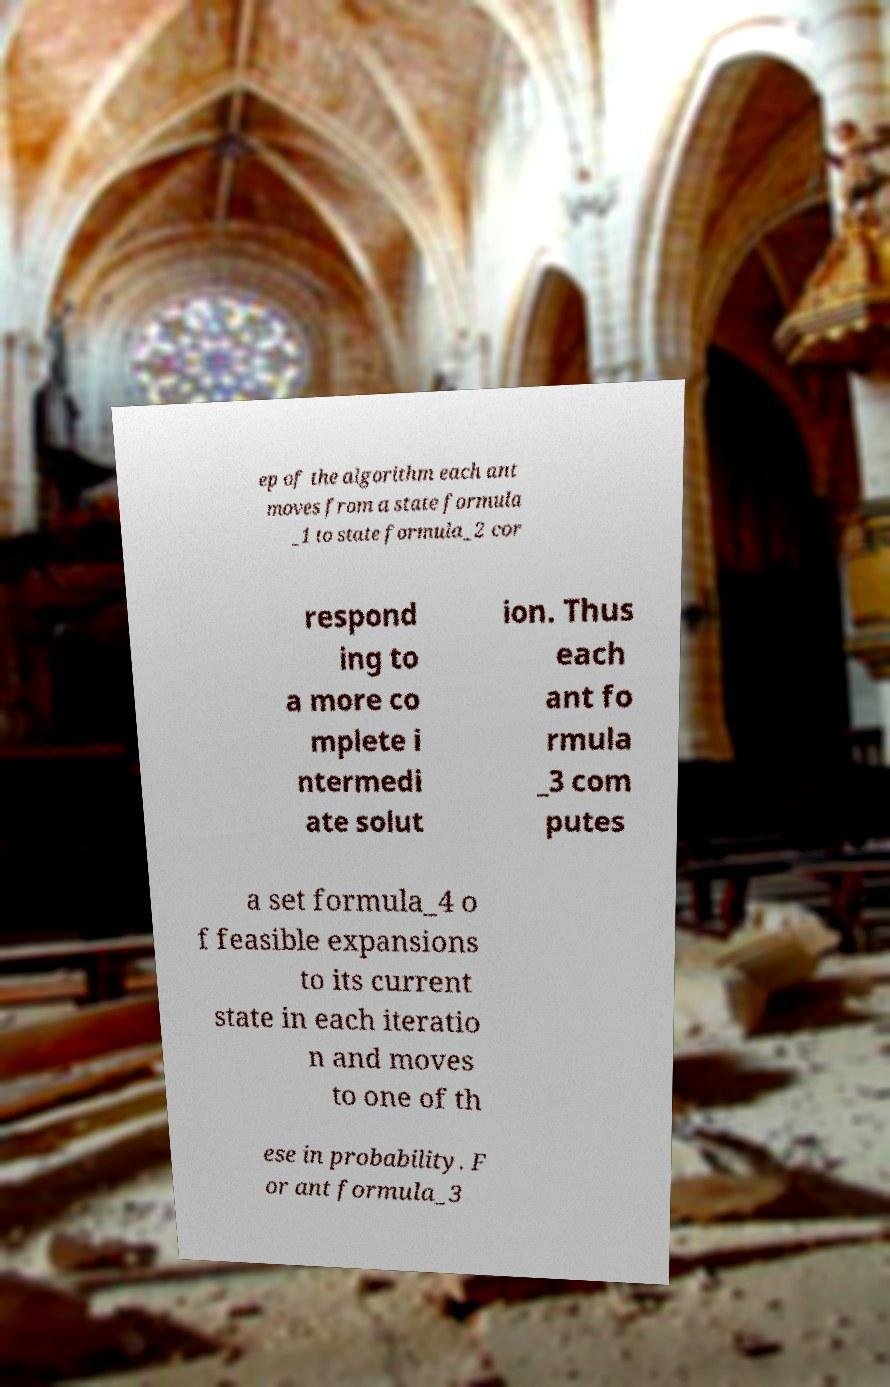Can you accurately transcribe the text from the provided image for me? ep of the algorithm each ant moves from a state formula _1 to state formula_2 cor respond ing to a more co mplete i ntermedi ate solut ion. Thus each ant fo rmula _3 com putes a set formula_4 o f feasible expansions to its current state in each iteratio n and moves to one of th ese in probability. F or ant formula_3 